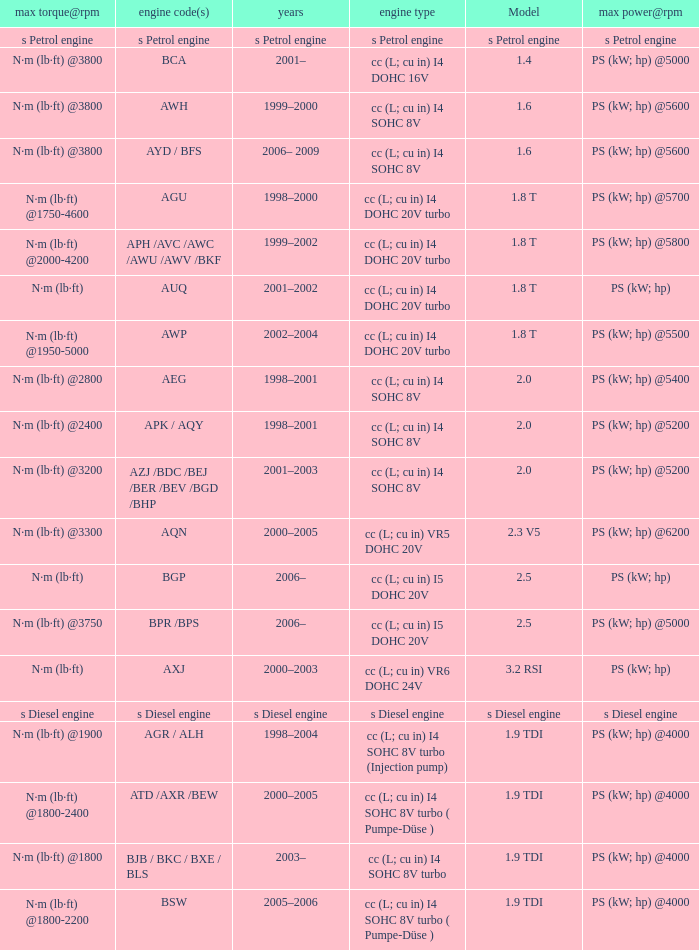Which engine type was used in the model 2.3 v5? Cc (l; cu in) vr5 dohc 20v. 